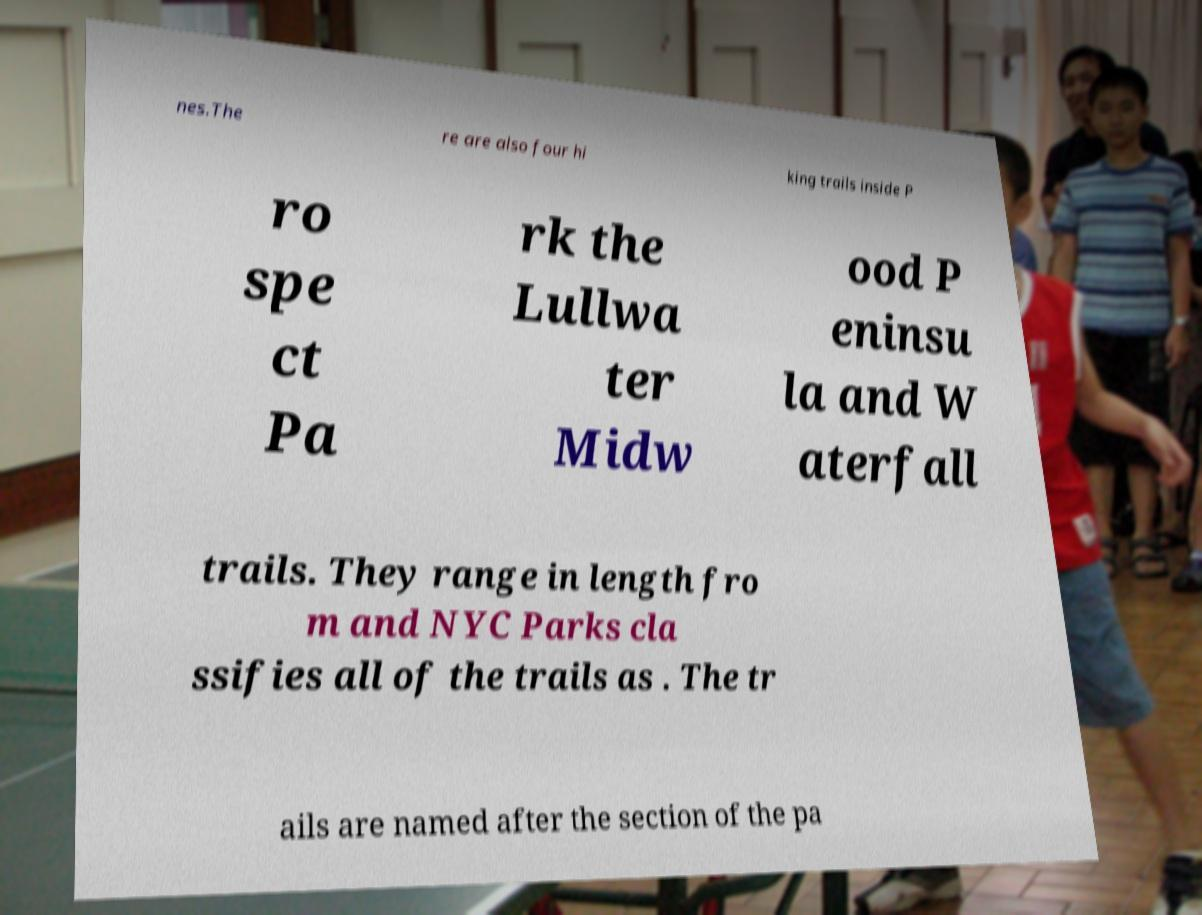For documentation purposes, I need the text within this image transcribed. Could you provide that? nes.The re are also four hi king trails inside P ro spe ct Pa rk the Lullwa ter Midw ood P eninsu la and W aterfall trails. They range in length fro m and NYC Parks cla ssifies all of the trails as . The tr ails are named after the section of the pa 